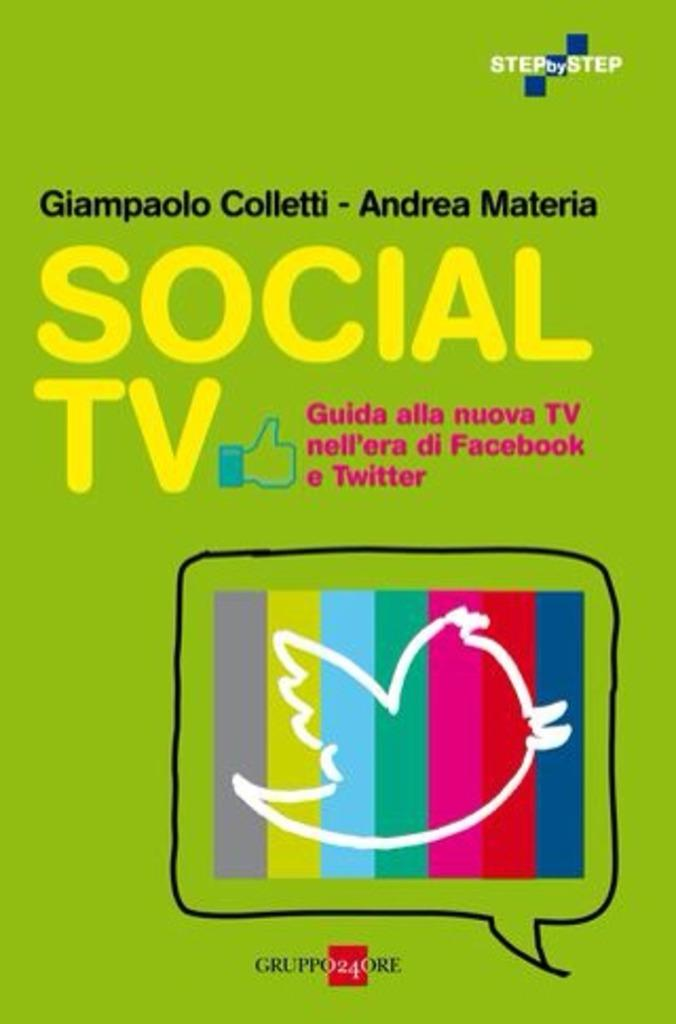<image>
Describe the image concisely. A green book cover for Social TV which is a guide to new media. 